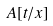<formula> <loc_0><loc_0><loc_500><loc_500>A [ t / x ]</formula> 